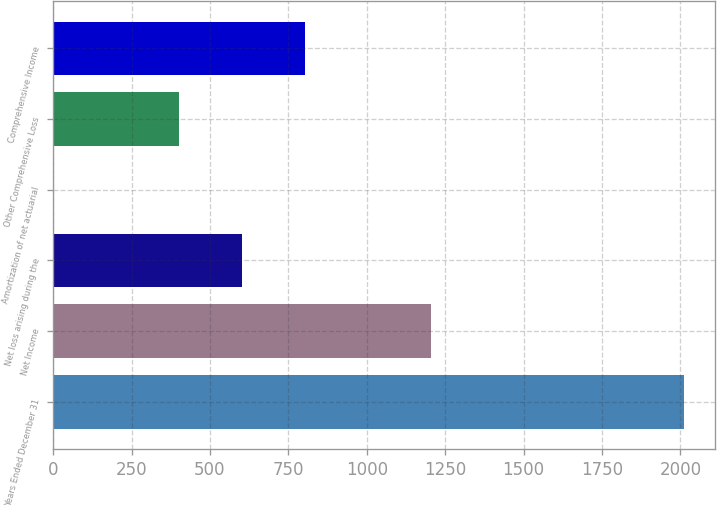<chart> <loc_0><loc_0><loc_500><loc_500><bar_chart><fcel>Years Ended December 31<fcel>Net Income<fcel>Net loss arising during the<fcel>Amortization of net actuarial<fcel>Other Comprehensive Loss<fcel>Comprehensive Income<nl><fcel>2010<fcel>1206.4<fcel>603.7<fcel>1<fcel>402.8<fcel>804.6<nl></chart> 